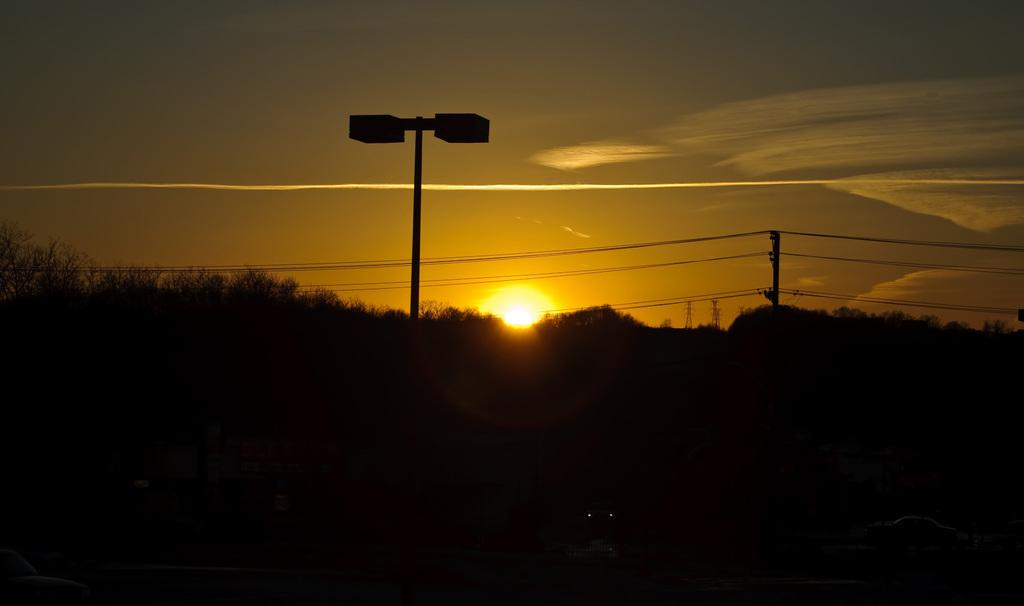What type of natural elements can be seen in the image? There are trees in the image. What man-made object is present in the image? There is a street lamp in the image. What celestial body is visible in the image? The moon is visible in the image. What part of the natural environment is visible in the image? The sky is visible in the image. How would you describe the lighting in the image? The image is slightly dark. How many dogs are playing in the image? There are no dogs present in the image. What type of vacation is depicted in the image? The image does not depict a vacation; it features trees, a street lamp, the moon, and the sky. 